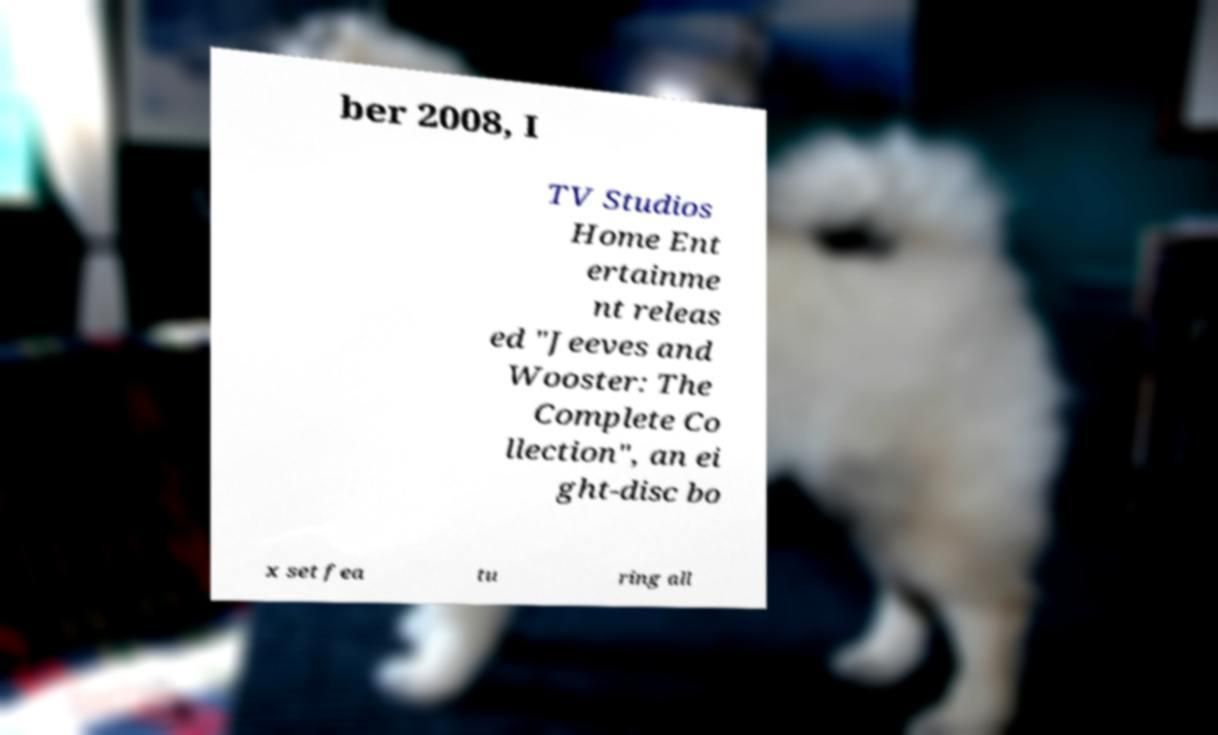Please read and relay the text visible in this image. What does it say? ber 2008, I TV Studios Home Ent ertainme nt releas ed "Jeeves and Wooster: The Complete Co llection", an ei ght-disc bo x set fea tu ring all 